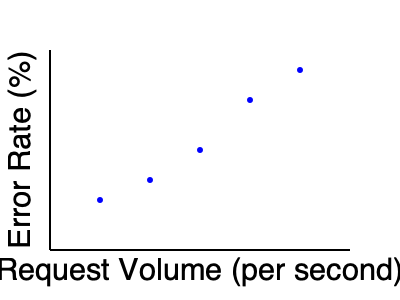As a Prometheus system administrator, you're analyzing a scatter plot of error rates versus request volume for your Prometheus server. What trend does this plot suggest about the relationship between request volume and error rate? To interpret this scatter plot, let's follow these steps:

1. Identify the axes:
   - X-axis represents Request Volume (per second)
   - Y-axis represents Error Rate (%)

2. Observe the data points:
   - There are 5 points plotted on the graph
   - As we move from left to right (increasing request volume), the points generally move downward (decreasing error rate)

3. Analyze the trend:
   - The points form a rough line from the upper-left to the lower-right of the plot
   - This indicates a negative correlation between request volume and error rate

4. Interpret the relationship:
   - As the request volume increases, the error rate tends to decrease
   - This suggests that the system performs better (with fewer errors) under higher load

5. Consider possible explanations:
   - The Prometheus server might be optimized for handling larger volumes of requests
   - There could be fixed overhead costs that become less significant as volume increases
   - The server might have more consistent performance under higher load due to continuous resource utilization

6. Implications for a Prometheus admin:
   - This trend suggests that the system is scalable and handles increased load well
   - It might be beneficial to ensure the server is consistently operating at higher capacities for optimal performance
Answer: Negative correlation: as request volume increases, error rate decreases. 